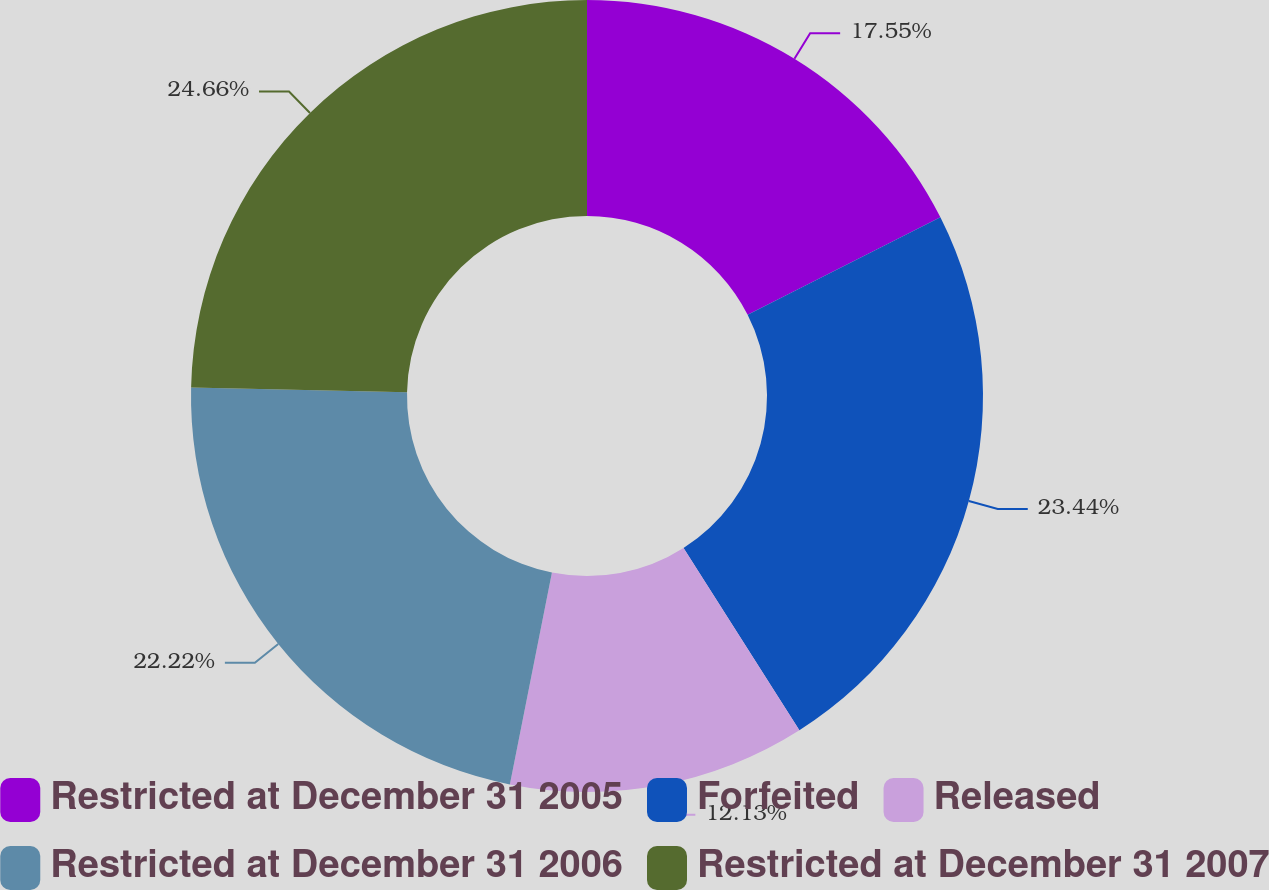Convert chart to OTSL. <chart><loc_0><loc_0><loc_500><loc_500><pie_chart><fcel>Restricted at December 31 2005<fcel>Forfeited<fcel>Released<fcel>Restricted at December 31 2006<fcel>Restricted at December 31 2007<nl><fcel>17.55%<fcel>23.44%<fcel>12.13%<fcel>22.22%<fcel>24.66%<nl></chart> 